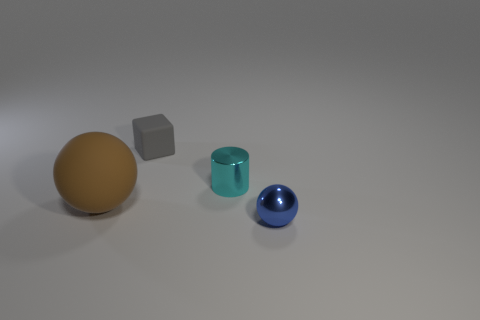What number of large things have the same color as the metal cylinder?
Keep it short and to the point. 0. Is the cyan thing the same shape as the brown rubber thing?
Your response must be concise. No. Are there any other things that have the same size as the brown matte ball?
Keep it short and to the point. No. There is another blue metal thing that is the same shape as the large object; what is its size?
Your answer should be compact. Small. Are there more small things that are in front of the cyan thing than cyan metal things that are behind the tiny gray rubber thing?
Your response must be concise. Yes. Is the small cyan cylinder made of the same material as the small thing that is to the right of the tiny cylinder?
Give a very brief answer. Yes. Is there any other thing that has the same shape as the large rubber object?
Your answer should be compact. Yes. The object that is left of the tiny cyan metallic thing and in front of the tiny matte block is what color?
Keep it short and to the point. Brown. The metal thing behind the brown matte thing has what shape?
Make the answer very short. Cylinder. What is the size of the object to the left of the gray cube behind the metallic object behind the small blue object?
Give a very brief answer. Large. 